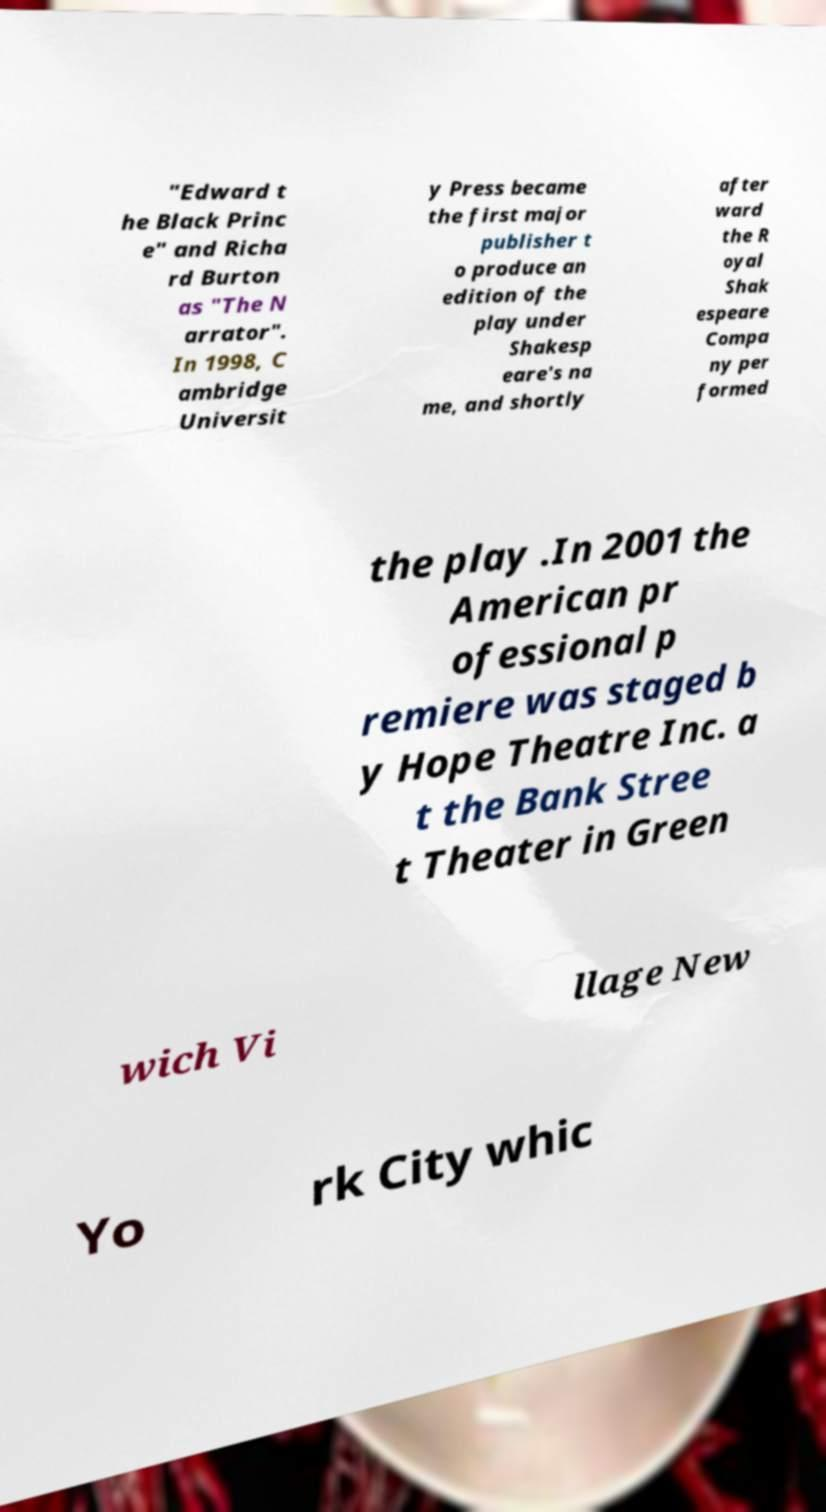Could you extract and type out the text from this image? "Edward t he Black Princ e" and Richa rd Burton as "The N arrator". In 1998, C ambridge Universit y Press became the first major publisher t o produce an edition of the play under Shakesp eare's na me, and shortly after ward the R oyal Shak espeare Compa ny per formed the play .In 2001 the American pr ofessional p remiere was staged b y Hope Theatre Inc. a t the Bank Stree t Theater in Green wich Vi llage New Yo rk City whic 